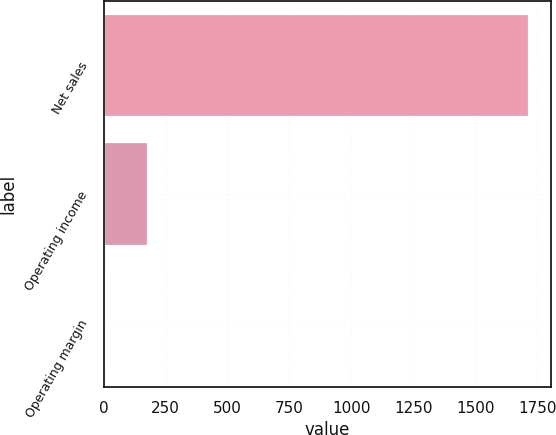<chart> <loc_0><loc_0><loc_500><loc_500><bar_chart><fcel>Net sales<fcel>Operating income<fcel>Operating margin<nl><fcel>1719<fcel>178.83<fcel>7.7<nl></chart> 